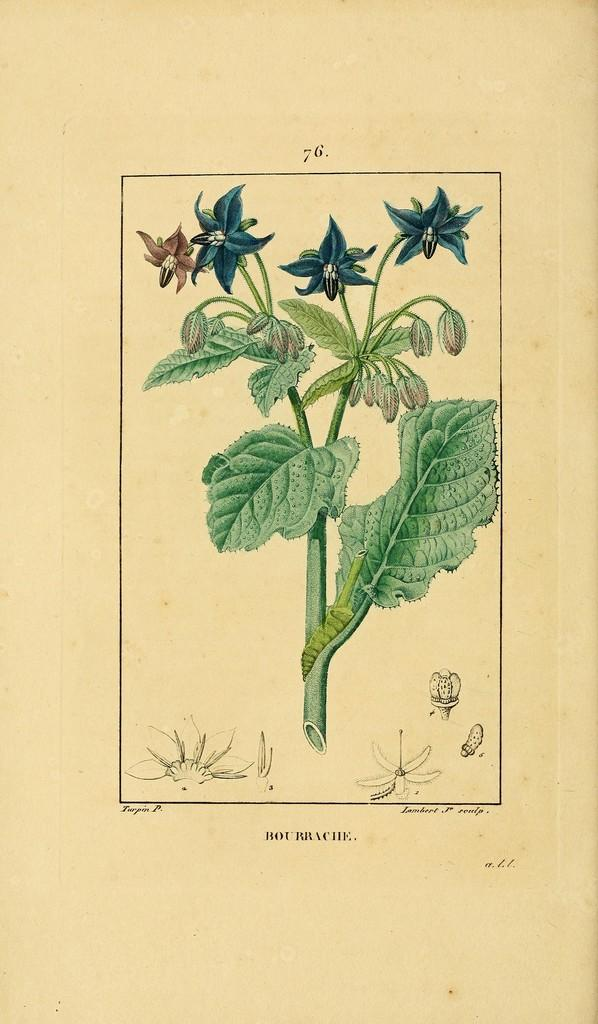What is the main subject of the drawing in the image? The main subject of the drawing in the image is a plant. What specific parts of the plant can be seen in the drawing? The plant has flowers, buds, and leaves in the drawing. Is there any text associated with the drawing in the image? Yes, there is text at the bottom of the image. How does the knife help the plant grow in the image? There is no knife present in the image, so it cannot help the plant grow. 